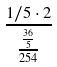<formula> <loc_0><loc_0><loc_500><loc_500>\frac { 1 / 5 \cdot 2 } { \frac { \frac { 3 6 } { 5 } } { 2 5 4 } }</formula> 